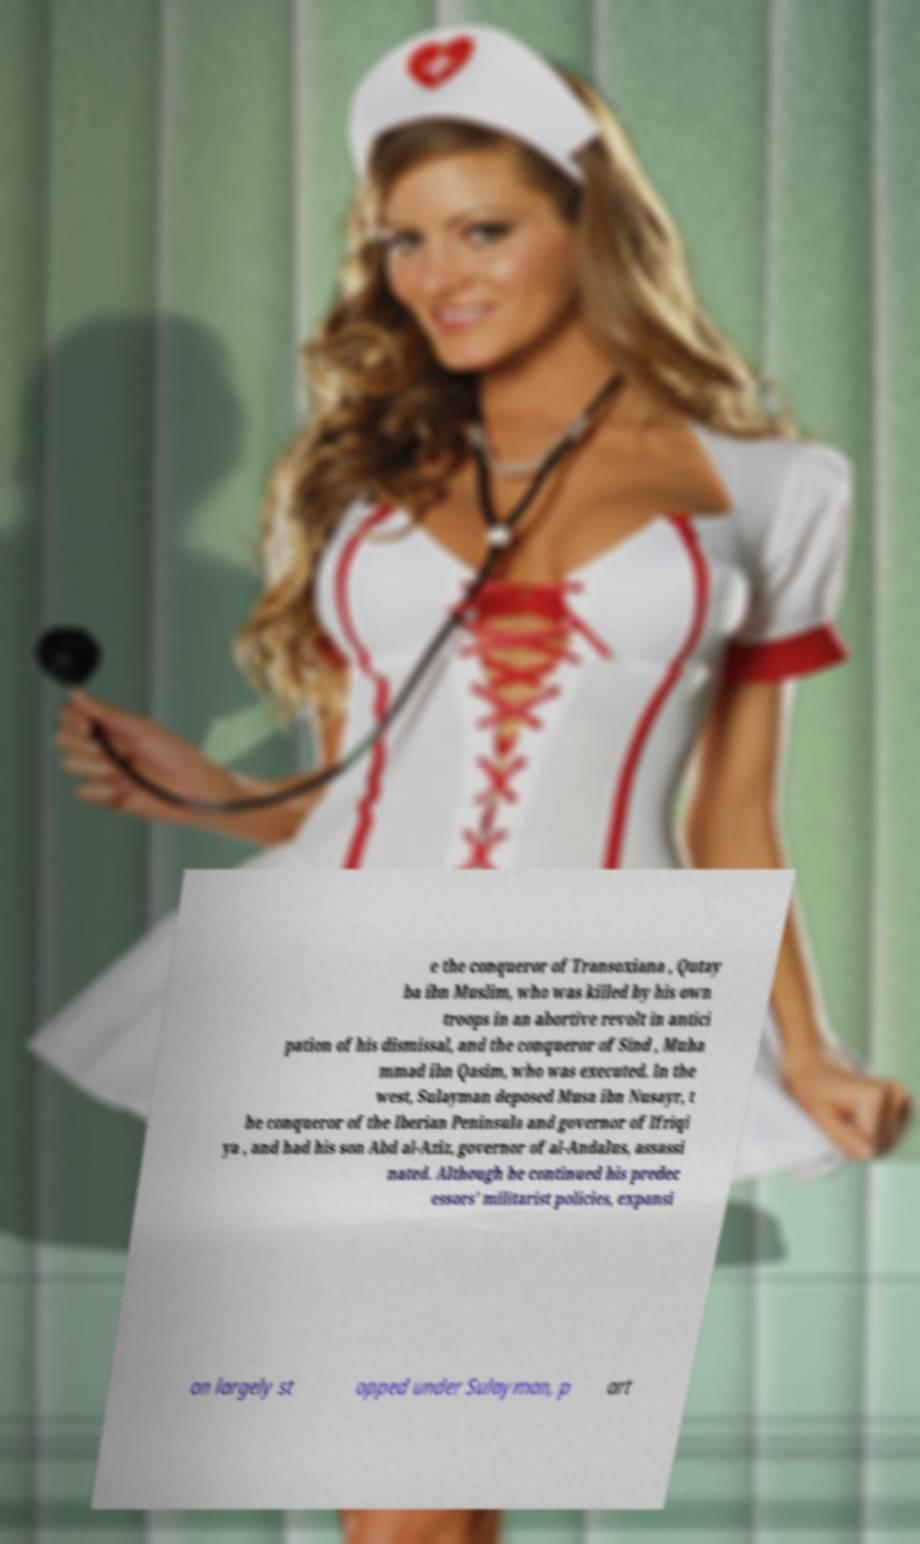Please read and relay the text visible in this image. What does it say? e the conqueror of Transoxiana , Qutay ba ibn Muslim, who was killed by his own troops in an abortive revolt in antici pation of his dismissal, and the conqueror of Sind , Muha mmad ibn Qasim, who was executed. In the west, Sulayman deposed Musa ibn Nusayr, t he conqueror of the Iberian Peninsula and governor of Ifriqi ya , and had his son Abd al-Aziz, governor of al-Andalus, assassi nated. Although he continued his predec essors' militarist policies, expansi on largely st opped under Sulayman, p art 